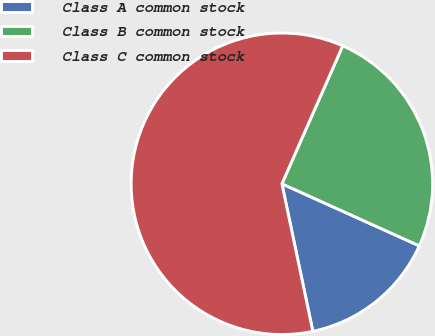<chart> <loc_0><loc_0><loc_500><loc_500><pie_chart><fcel>Class A common stock<fcel>Class B common stock<fcel>Class C common stock<nl><fcel>14.96%<fcel>25.14%<fcel>59.9%<nl></chart> 